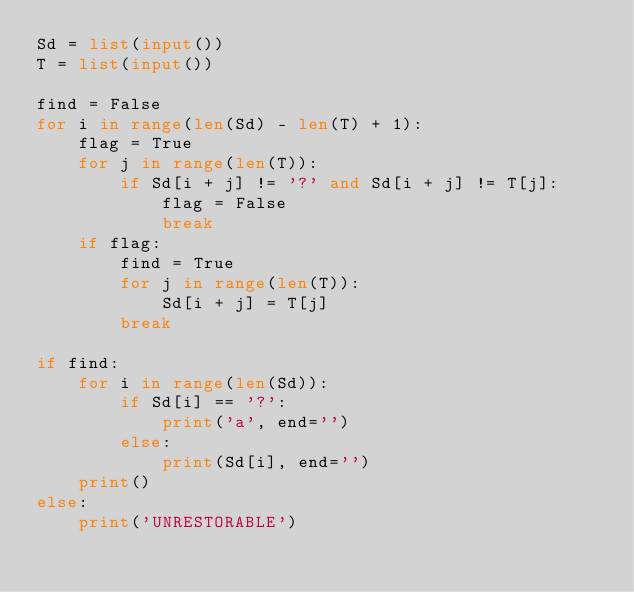<code> <loc_0><loc_0><loc_500><loc_500><_Python_>Sd = list(input())
T = list(input())

find = False
for i in range(len(Sd) - len(T) + 1):
    flag = True
    for j in range(len(T)):
        if Sd[i + j] != '?' and Sd[i + j] != T[j]:
            flag = False
            break
    if flag:
        find = True
        for j in range(len(T)):
            Sd[i + j] = T[j]
        break

if find:
    for i in range(len(Sd)):
        if Sd[i] == '?':
            print('a', end='')
        else:
            print(Sd[i], end='')
    print()
else:
    print('UNRESTORABLE')</code> 